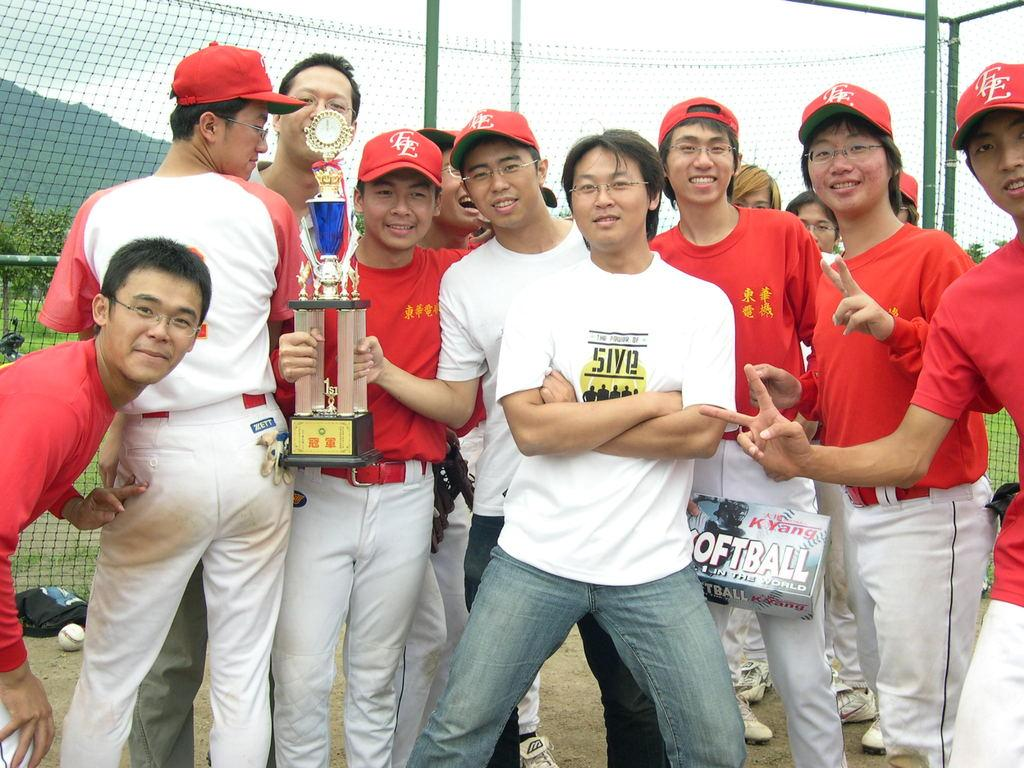<image>
Give a short and clear explanation of the subsequent image. The trophy shows these guys just one 1st place in softball. 